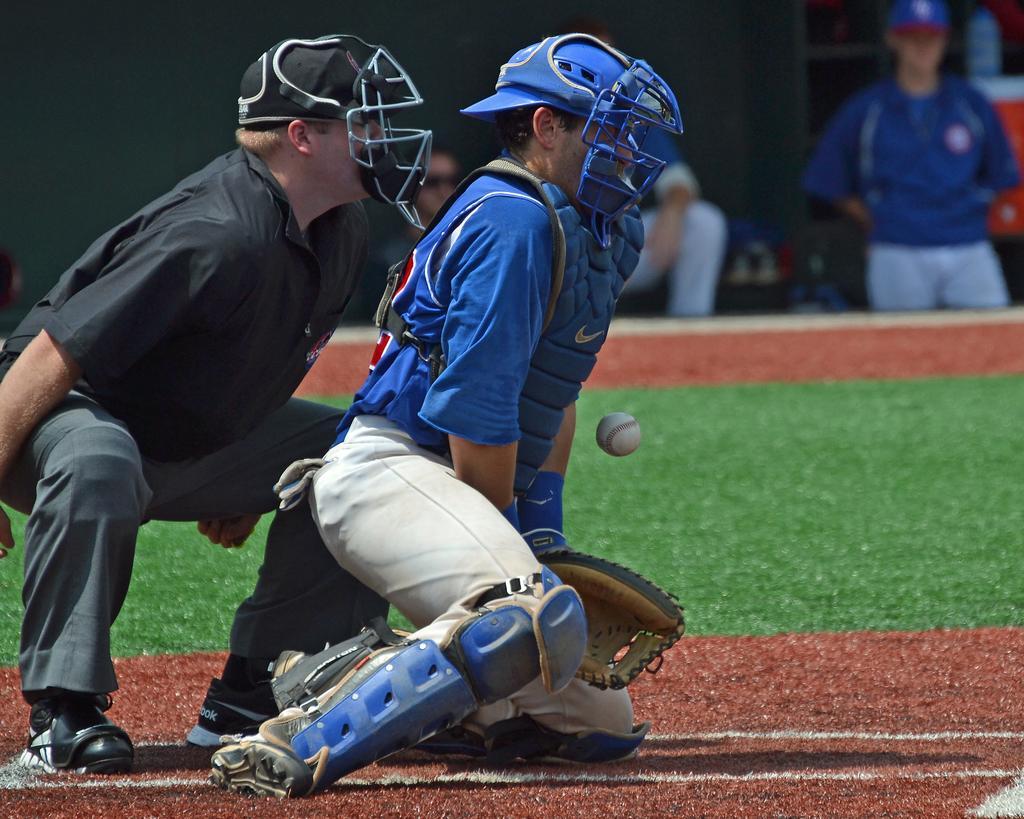Could you give a brief overview of what you see in this image? In the picture I can see two persons crouching and there is a ball in front of them and there is a greenery ground beside them and there are few other persons in the background. 